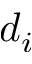<formula> <loc_0><loc_0><loc_500><loc_500>d _ { i }</formula> 